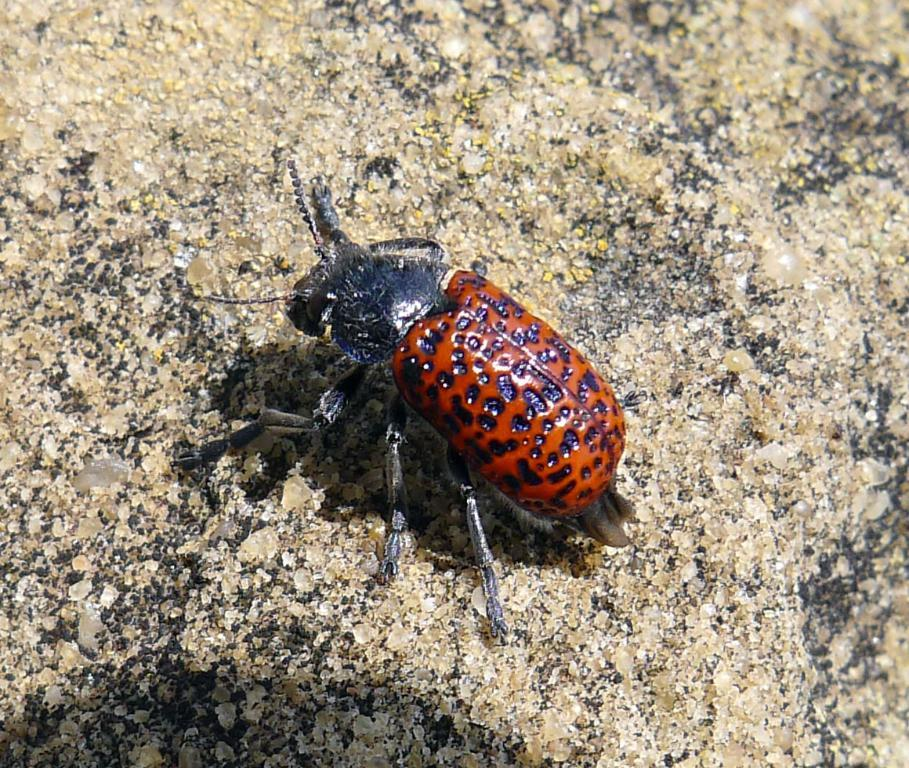What is present on the ground in the image? There is an insect on the ground in the image. Can you describe the insect's location more specifically? The insect is on the ground, but no further details about its exact position are provided. Based on the lighting in the image, can you determine the time of day it was taken? The image was likely taken during the day, as there is sufficient light to see the insect clearly. How does the insect express its feelings in the image? Insects do not have the ability to express feelings, so this question cannot be answered based on the image. 